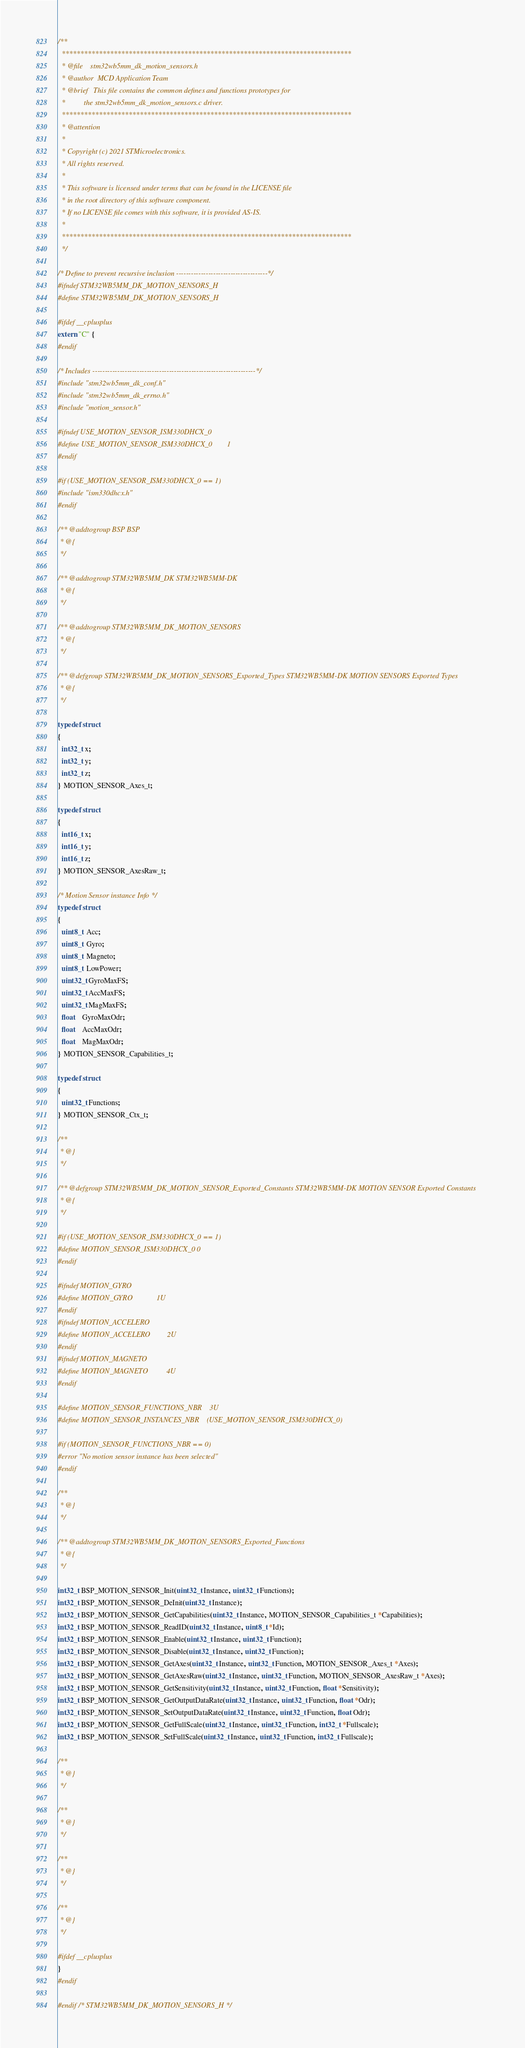<code> <loc_0><loc_0><loc_500><loc_500><_C_>/**
  ******************************************************************************
  * @file    stm32wb5mm_dk_motion_sensors.h
  * @author  MCD Application Team
  * @brief   This file contains the common defines and functions prototypes for
  *          the stm32wb5mm_dk_motion_sensors.c driver.
  ******************************************************************************
  * @attention
  *
  * Copyright (c) 2021 STMicroelectronics.
  * All rights reserved.
  *
  * This software is licensed under terms that can be found in the LICENSE file
  * in the root directory of this software component.
  * If no LICENSE file comes with this software, it is provided AS-IS.
  *
  ******************************************************************************
  */

/* Define to prevent recursive inclusion -------------------------------------*/
#ifndef STM32WB5MM_DK_MOTION_SENSORS_H
#define STM32WB5MM_DK_MOTION_SENSORS_H

#ifdef __cplusplus
extern "C" {
#endif

/* Includes ------------------------------------------------------------------*/
#include "stm32wb5mm_dk_conf.h"
#include "stm32wb5mm_dk_errno.h"
#include "motion_sensor.h"

#ifndef USE_MOTION_SENSOR_ISM330DHCX_0
#define USE_MOTION_SENSOR_ISM330DHCX_0        1
#endif

#if (USE_MOTION_SENSOR_ISM330DHCX_0 == 1)
#include "ism330dhcx.h"
#endif

/** @addtogroup BSP BSP
 * @{
 */

/** @addtogroup STM32WB5MM_DK STM32WB5MM-DK
 * @{
 */

/** @addtogroup STM32WB5MM_DK_MOTION_SENSORS
 * @{
 */

/** @defgroup STM32WB5MM_DK_MOTION_SENSORS_Exported_Types STM32WB5MM-DK MOTION SENSORS Exported Types
 * @{
 */

typedef struct
{
  int32_t x;
  int32_t y;
  int32_t z;
} MOTION_SENSOR_Axes_t;

typedef struct
{
  int16_t x;
  int16_t y;
  int16_t z;
} MOTION_SENSOR_AxesRaw_t;

/* Motion Sensor instance Info */
typedef struct
{
  uint8_t  Acc;
  uint8_t  Gyro;
  uint8_t  Magneto;
  uint8_t  LowPower;
  uint32_t GyroMaxFS;
  uint32_t AccMaxFS;
  uint32_t MagMaxFS;
  float    GyroMaxOdr;
  float    AccMaxOdr;
  float    MagMaxOdr;
} MOTION_SENSOR_Capabilities_t;

typedef struct
{
  uint32_t Functions;
} MOTION_SENSOR_Ctx_t;

/**
 * @}
 */

/** @defgroup STM32WB5MM_DK_MOTION_SENSOR_Exported_Constants STM32WB5MM-DK MOTION SENSOR Exported Constants
 * @{
 */

#if (USE_MOTION_SENSOR_ISM330DHCX_0 == 1)
#define MOTION_SENSOR_ISM330DHCX_0 0
#endif

#ifndef MOTION_GYRO
#define MOTION_GYRO             1U
#endif
#ifndef MOTION_ACCELERO
#define MOTION_ACCELERO         2U
#endif
#ifndef MOTION_MAGNETO
#define MOTION_MAGNETO          4U
#endif

#define MOTION_SENSOR_FUNCTIONS_NBR    3U
#define MOTION_SENSOR_INSTANCES_NBR    (USE_MOTION_SENSOR_ISM330DHCX_0)

#if (MOTION_SENSOR_FUNCTIONS_NBR == 0)
#error "No motion sensor instance has been selected"
#endif

/**
 * @}
 */

/** @addtogroup STM32WB5MM_DK_MOTION_SENSORS_Exported_Functions
 * @{
 */

int32_t BSP_MOTION_SENSOR_Init(uint32_t Instance, uint32_t Functions);
int32_t BSP_MOTION_SENSOR_DeInit(uint32_t Instance);
int32_t BSP_MOTION_SENSOR_GetCapabilities(uint32_t Instance, MOTION_SENSOR_Capabilities_t *Capabilities);
int32_t BSP_MOTION_SENSOR_ReadID(uint32_t Instance, uint8_t *Id);
int32_t BSP_MOTION_SENSOR_Enable(uint32_t Instance, uint32_t Function);
int32_t BSP_MOTION_SENSOR_Disable(uint32_t Instance, uint32_t Function);
int32_t BSP_MOTION_SENSOR_GetAxes(uint32_t Instance, uint32_t Function, MOTION_SENSOR_Axes_t *Axes);
int32_t BSP_MOTION_SENSOR_GetAxesRaw(uint32_t Instance, uint32_t Function, MOTION_SENSOR_AxesRaw_t *Axes);
int32_t BSP_MOTION_SENSOR_GetSensitivity(uint32_t Instance, uint32_t Function, float *Sensitivity);
int32_t BSP_MOTION_SENSOR_GetOutputDataRate(uint32_t Instance, uint32_t Function, float *Odr);
int32_t BSP_MOTION_SENSOR_SetOutputDataRate(uint32_t Instance, uint32_t Function, float Odr);
int32_t BSP_MOTION_SENSOR_GetFullScale(uint32_t Instance, uint32_t Function, int32_t *Fullscale);
int32_t BSP_MOTION_SENSOR_SetFullScale(uint32_t Instance, uint32_t Function, int32_t Fullscale);

/**
 * @}
 */

/**
 * @}
 */

/**
 * @}
 */

/**
 * @}
 */

#ifdef __cplusplus
}
#endif

#endif /* STM32WB5MM_DK_MOTION_SENSORS_H */
</code> 